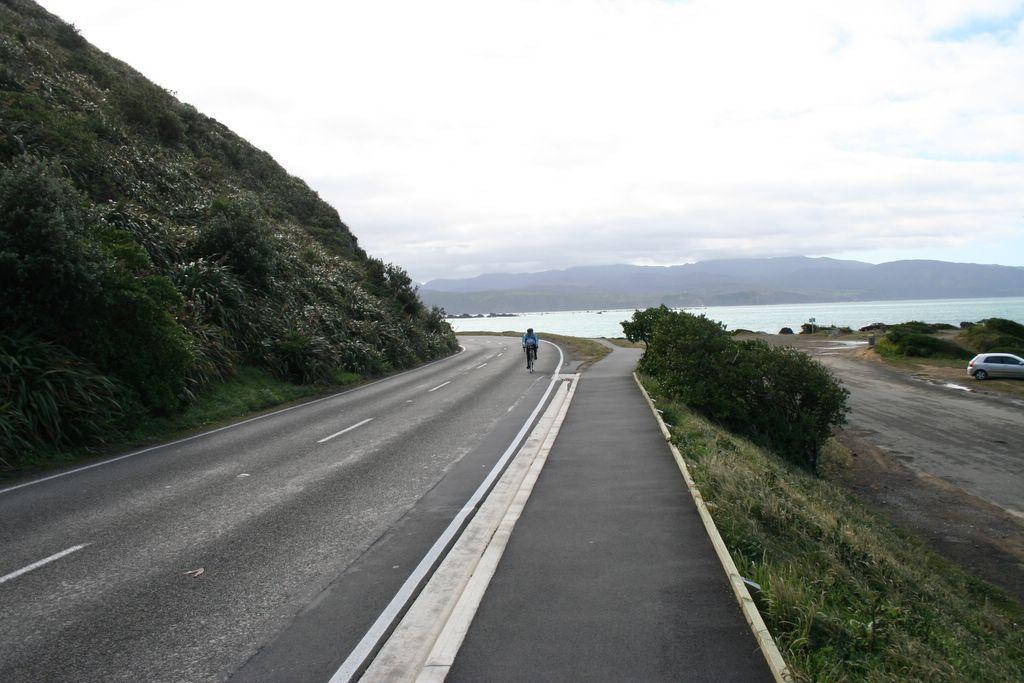What is the person in the image doing? The person is riding a bicycle on the road. What type of vegetation can be seen in the image? There are plants and grass visible in the image. What other living creature is present in the image? There is a cat in the image. What natural feature can be seen in the distance? There is a mountain in the image. What is visible in the background of the image? The sky is visible in the background of the image. What is the weight of the map in the image? There is no map present in the image, so it is not possible to determine its weight. 